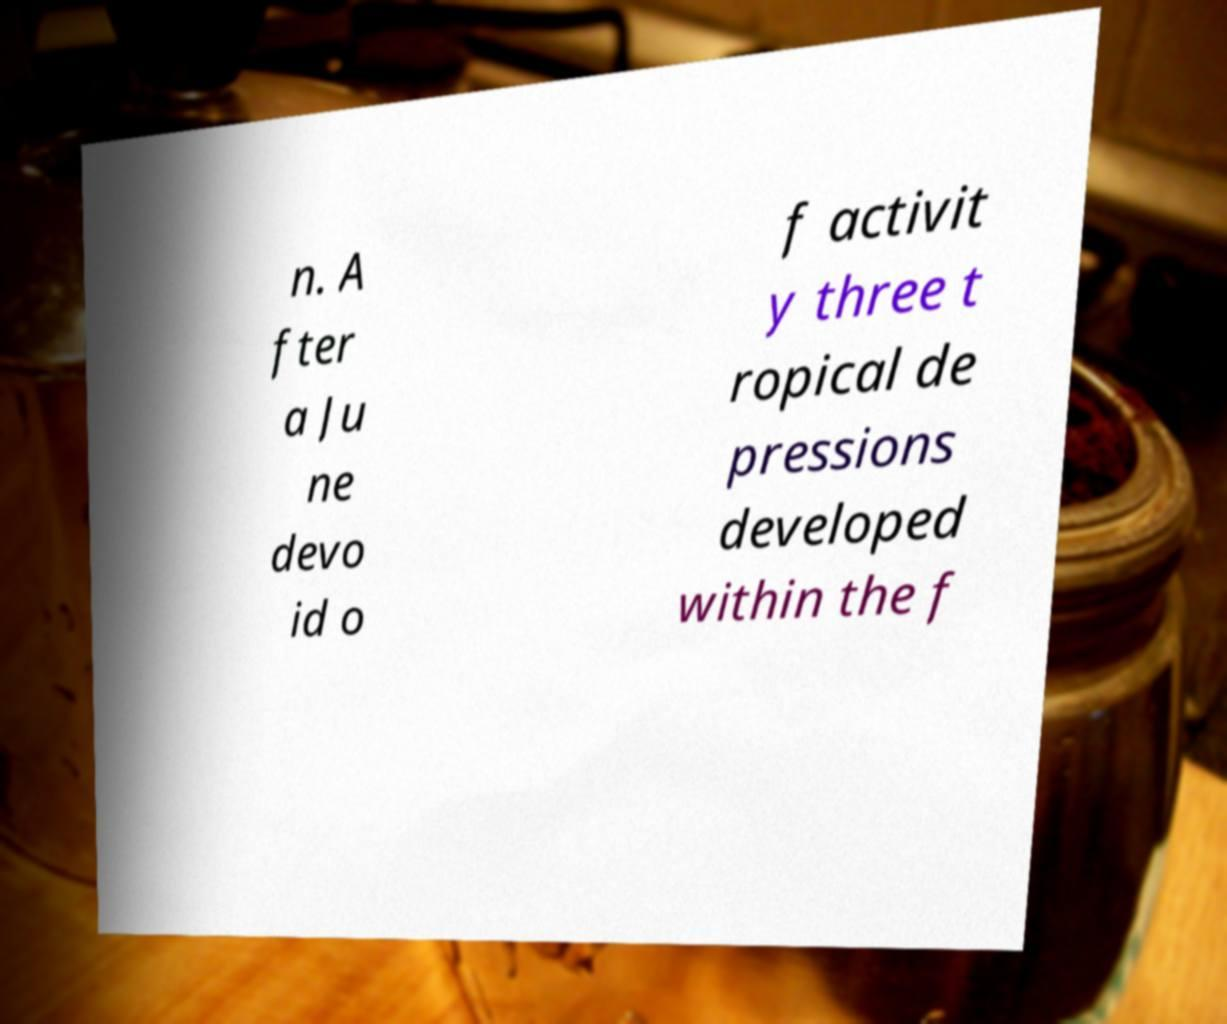Please read and relay the text visible in this image. What does it say? n. A fter a Ju ne devo id o f activit y three t ropical de pressions developed within the f 